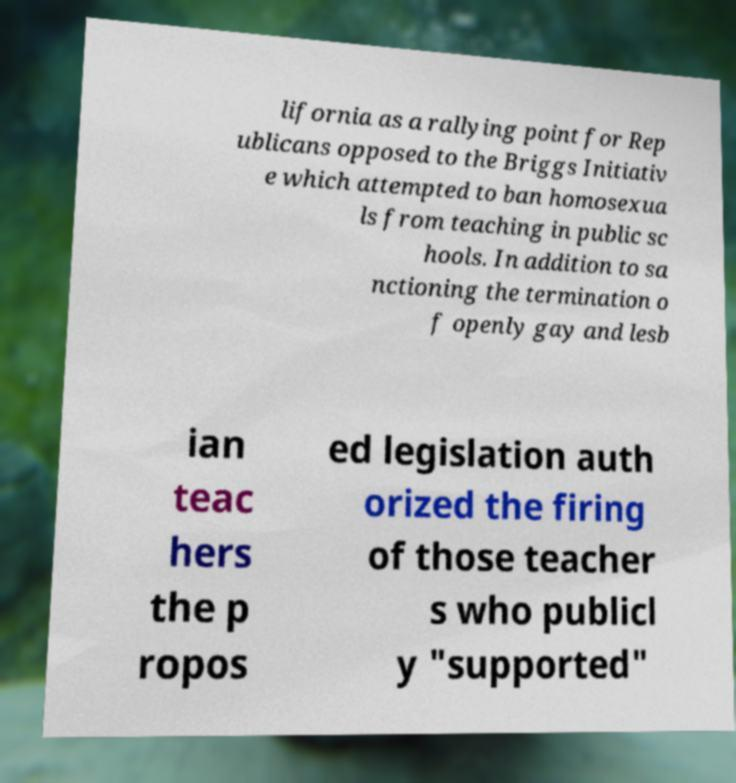Please identify and transcribe the text found in this image. lifornia as a rallying point for Rep ublicans opposed to the Briggs Initiativ e which attempted to ban homosexua ls from teaching in public sc hools. In addition to sa nctioning the termination o f openly gay and lesb ian teac hers the p ropos ed legislation auth orized the firing of those teacher s who publicl y "supported" 